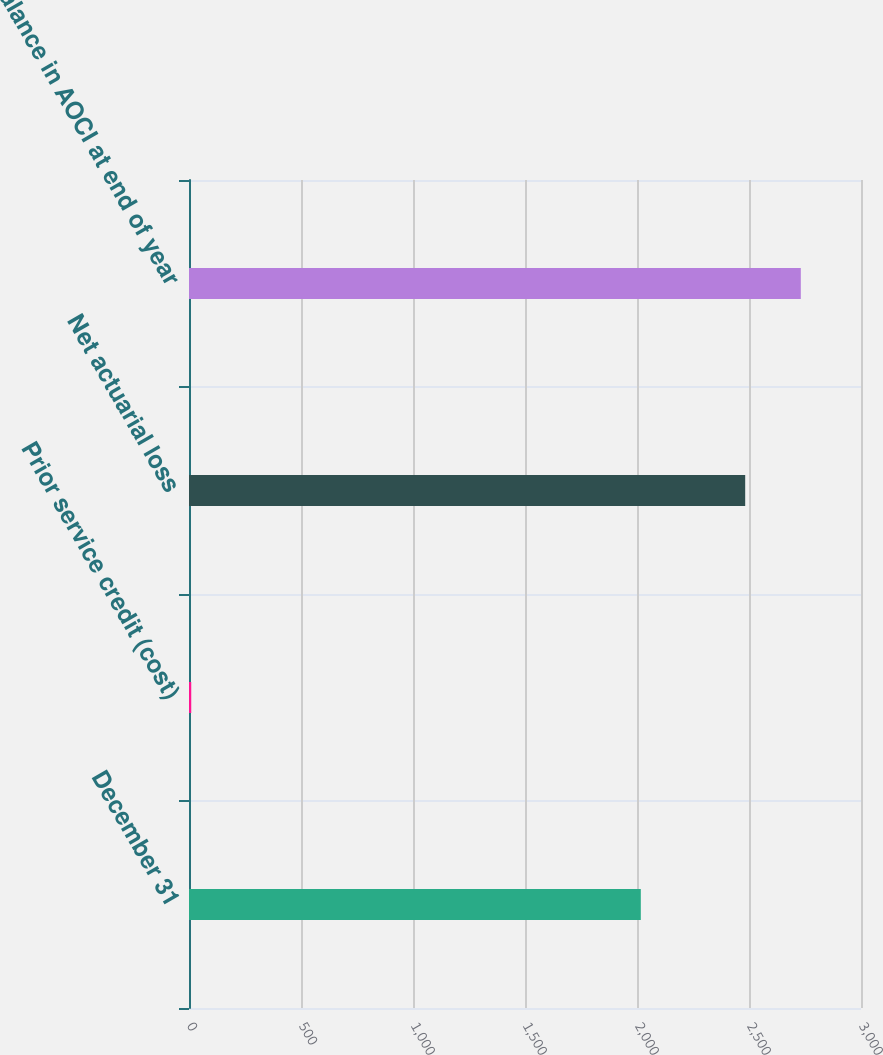Convert chart. <chart><loc_0><loc_0><loc_500><loc_500><bar_chart><fcel>December 31<fcel>Prior service credit (cost)<fcel>Net actuarial loss<fcel>Balance in AOCI at end of year<nl><fcel>2017<fcel>10<fcel>2483<fcel>2731.3<nl></chart> 